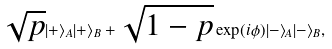Convert formula to latex. <formula><loc_0><loc_0><loc_500><loc_500>\sqrt { p } | + \rangle _ { A } | + \rangle _ { B } + \sqrt { 1 - p } \exp ( i \phi ) | - \rangle _ { A } | - \rangle _ { B } ,</formula> 